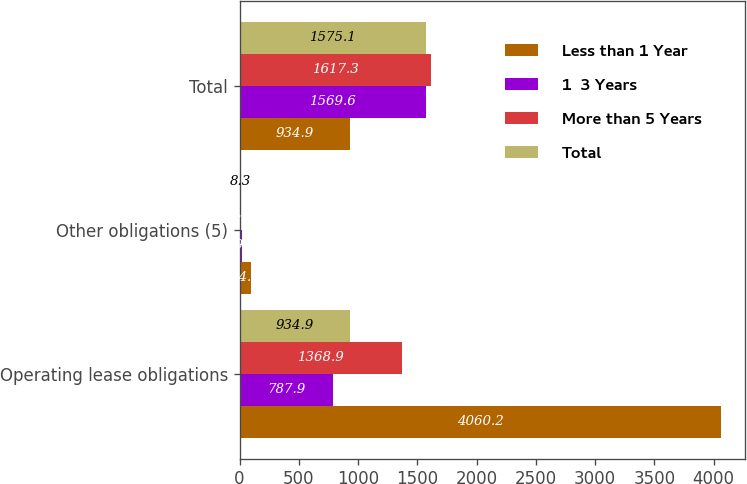<chart> <loc_0><loc_0><loc_500><loc_500><stacked_bar_chart><ecel><fcel>Operating lease obligations<fcel>Other obligations (5)<fcel>Total<nl><fcel>Less than 1 Year<fcel>4060.2<fcel>94.9<fcel>934.9<nl><fcel>1  3 Years<fcel>787.9<fcel>19.4<fcel>1569.6<nl><fcel>More than 5 Years<fcel>1368.9<fcel>9.6<fcel>1617.3<nl><fcel>Total<fcel>934.9<fcel>8.3<fcel>1575.1<nl></chart> 